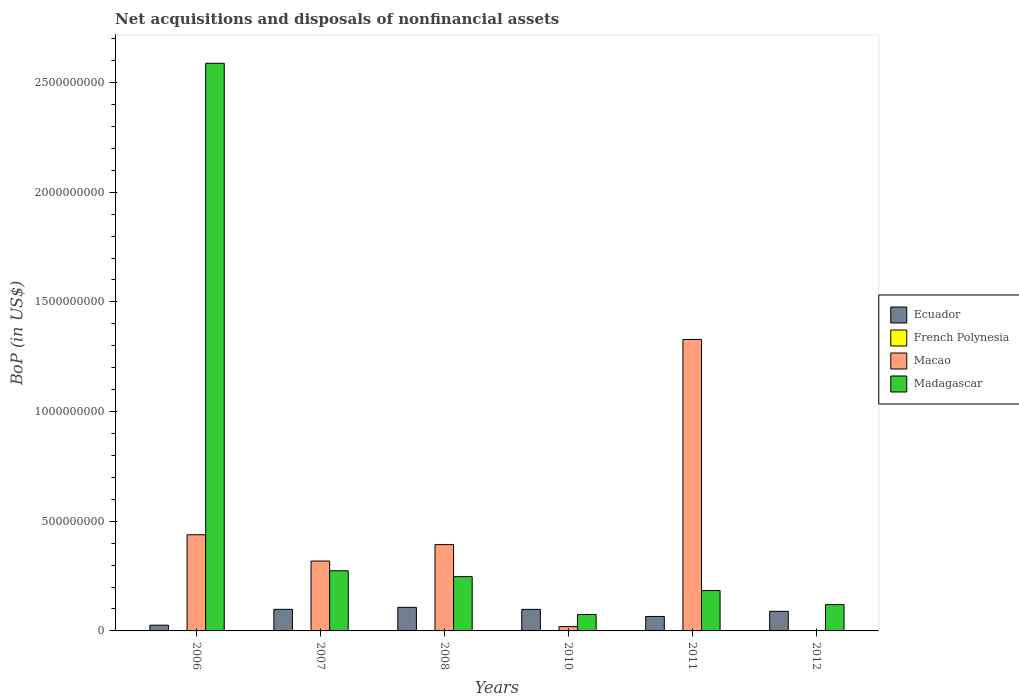How many different coloured bars are there?
Give a very brief answer. 4. How many groups of bars are there?
Give a very brief answer. 6. Are the number of bars per tick equal to the number of legend labels?
Give a very brief answer. No. Are the number of bars on each tick of the X-axis equal?
Your answer should be compact. No. How many bars are there on the 6th tick from the left?
Provide a succinct answer. 2. How many bars are there on the 4th tick from the right?
Give a very brief answer. 4. What is the Balance of Payments in Madagascar in 2011?
Offer a very short reply. 1.84e+08. Across all years, what is the maximum Balance of Payments in Madagascar?
Your response must be concise. 2.59e+09. Across all years, what is the minimum Balance of Payments in French Polynesia?
Your answer should be very brief. 0. What is the total Balance of Payments in Macao in the graph?
Offer a terse response. 2.50e+09. What is the difference between the Balance of Payments in Macao in 2006 and that in 2011?
Provide a succinct answer. -8.90e+08. What is the difference between the Balance of Payments in Madagascar in 2008 and the Balance of Payments in Ecuador in 2011?
Provide a short and direct response. 1.81e+08. What is the average Balance of Payments in Madagascar per year?
Keep it short and to the point. 5.81e+08. In the year 2008, what is the difference between the Balance of Payments in French Polynesia and Balance of Payments in Ecuador?
Your answer should be very brief. -1.07e+08. In how many years, is the Balance of Payments in French Polynesia greater than 100000000 US$?
Your answer should be compact. 0. What is the ratio of the Balance of Payments in Ecuador in 2008 to that in 2010?
Offer a terse response. 1.09. Is the Balance of Payments in Madagascar in 2010 less than that in 2012?
Your answer should be compact. Yes. What is the difference between the highest and the second highest Balance of Payments in Madagascar?
Your answer should be very brief. 2.31e+09. What is the difference between the highest and the lowest Balance of Payments in Ecuador?
Offer a very short reply. 8.13e+07. In how many years, is the Balance of Payments in Macao greater than the average Balance of Payments in Macao taken over all years?
Offer a very short reply. 2. Is it the case that in every year, the sum of the Balance of Payments in Ecuador and Balance of Payments in French Polynesia is greater than the Balance of Payments in Madagascar?
Give a very brief answer. No. Are all the bars in the graph horizontal?
Offer a very short reply. No. What is the difference between two consecutive major ticks on the Y-axis?
Offer a terse response. 5.00e+08. Are the values on the major ticks of Y-axis written in scientific E-notation?
Ensure brevity in your answer.  No. Does the graph contain grids?
Ensure brevity in your answer.  No. How are the legend labels stacked?
Your answer should be compact. Vertical. What is the title of the graph?
Ensure brevity in your answer.  Net acquisitions and disposals of nonfinancial assets. What is the label or title of the X-axis?
Give a very brief answer. Years. What is the label or title of the Y-axis?
Offer a very short reply. BoP (in US$). What is the BoP (in US$) in Ecuador in 2006?
Your answer should be compact. 2.61e+07. What is the BoP (in US$) in French Polynesia in 2006?
Your answer should be very brief. 0. What is the BoP (in US$) of Macao in 2006?
Give a very brief answer. 4.38e+08. What is the BoP (in US$) of Madagascar in 2006?
Offer a very short reply. 2.59e+09. What is the BoP (in US$) in Ecuador in 2007?
Offer a very short reply. 9.84e+07. What is the BoP (in US$) in French Polynesia in 2007?
Your answer should be very brief. 0. What is the BoP (in US$) in Macao in 2007?
Give a very brief answer. 3.19e+08. What is the BoP (in US$) of Madagascar in 2007?
Provide a short and direct response. 2.74e+08. What is the BoP (in US$) in Ecuador in 2008?
Offer a very short reply. 1.07e+08. What is the BoP (in US$) in French Polynesia in 2008?
Provide a short and direct response. 8350.98. What is the BoP (in US$) of Macao in 2008?
Offer a terse response. 3.93e+08. What is the BoP (in US$) of Madagascar in 2008?
Keep it short and to the point. 2.47e+08. What is the BoP (in US$) in Ecuador in 2010?
Your response must be concise. 9.82e+07. What is the BoP (in US$) in French Polynesia in 2010?
Your answer should be compact. 0. What is the BoP (in US$) in Macao in 2010?
Offer a terse response. 1.96e+07. What is the BoP (in US$) in Madagascar in 2010?
Your response must be concise. 7.49e+07. What is the BoP (in US$) of Ecuador in 2011?
Provide a short and direct response. 6.60e+07. What is the BoP (in US$) in French Polynesia in 2011?
Your answer should be very brief. 0. What is the BoP (in US$) in Macao in 2011?
Your response must be concise. 1.33e+09. What is the BoP (in US$) in Madagascar in 2011?
Ensure brevity in your answer.  1.84e+08. What is the BoP (in US$) of Ecuador in 2012?
Make the answer very short. 8.94e+07. What is the BoP (in US$) of French Polynesia in 2012?
Your answer should be compact. 0. What is the BoP (in US$) in Madagascar in 2012?
Keep it short and to the point. 1.20e+08. Across all years, what is the maximum BoP (in US$) in Ecuador?
Offer a terse response. 1.07e+08. Across all years, what is the maximum BoP (in US$) in French Polynesia?
Offer a very short reply. 8350.98. Across all years, what is the maximum BoP (in US$) in Macao?
Your answer should be very brief. 1.33e+09. Across all years, what is the maximum BoP (in US$) of Madagascar?
Offer a terse response. 2.59e+09. Across all years, what is the minimum BoP (in US$) of Ecuador?
Offer a terse response. 2.61e+07. Across all years, what is the minimum BoP (in US$) of French Polynesia?
Give a very brief answer. 0. Across all years, what is the minimum BoP (in US$) of Macao?
Your answer should be very brief. 0. Across all years, what is the minimum BoP (in US$) in Madagascar?
Make the answer very short. 7.49e+07. What is the total BoP (in US$) of Ecuador in the graph?
Offer a very short reply. 4.86e+08. What is the total BoP (in US$) of French Polynesia in the graph?
Provide a short and direct response. 8350.98. What is the total BoP (in US$) in Macao in the graph?
Give a very brief answer. 2.50e+09. What is the total BoP (in US$) of Madagascar in the graph?
Your answer should be very brief. 3.49e+09. What is the difference between the BoP (in US$) of Ecuador in 2006 and that in 2007?
Offer a terse response. -7.23e+07. What is the difference between the BoP (in US$) in Macao in 2006 and that in 2007?
Offer a very short reply. 1.20e+08. What is the difference between the BoP (in US$) in Madagascar in 2006 and that in 2007?
Ensure brevity in your answer.  2.31e+09. What is the difference between the BoP (in US$) of Ecuador in 2006 and that in 2008?
Your answer should be very brief. -8.13e+07. What is the difference between the BoP (in US$) of Macao in 2006 and that in 2008?
Your answer should be very brief. 4.50e+07. What is the difference between the BoP (in US$) in Madagascar in 2006 and that in 2008?
Provide a short and direct response. 2.34e+09. What is the difference between the BoP (in US$) of Ecuador in 2006 and that in 2010?
Your answer should be very brief. -7.21e+07. What is the difference between the BoP (in US$) of Macao in 2006 and that in 2010?
Your response must be concise. 4.19e+08. What is the difference between the BoP (in US$) of Madagascar in 2006 and that in 2010?
Provide a succinct answer. 2.51e+09. What is the difference between the BoP (in US$) of Ecuador in 2006 and that in 2011?
Make the answer very short. -3.99e+07. What is the difference between the BoP (in US$) in Macao in 2006 and that in 2011?
Your response must be concise. -8.90e+08. What is the difference between the BoP (in US$) in Madagascar in 2006 and that in 2011?
Offer a terse response. 2.40e+09. What is the difference between the BoP (in US$) in Ecuador in 2006 and that in 2012?
Ensure brevity in your answer.  -6.33e+07. What is the difference between the BoP (in US$) in Madagascar in 2006 and that in 2012?
Provide a short and direct response. 2.47e+09. What is the difference between the BoP (in US$) of Ecuador in 2007 and that in 2008?
Provide a short and direct response. -9.01e+06. What is the difference between the BoP (in US$) of Macao in 2007 and that in 2008?
Offer a very short reply. -7.49e+07. What is the difference between the BoP (in US$) of Madagascar in 2007 and that in 2008?
Your answer should be compact. 2.68e+07. What is the difference between the BoP (in US$) of Ecuador in 2007 and that in 2010?
Your response must be concise. 1.95e+05. What is the difference between the BoP (in US$) of Macao in 2007 and that in 2010?
Give a very brief answer. 2.99e+08. What is the difference between the BoP (in US$) of Madagascar in 2007 and that in 2010?
Provide a succinct answer. 1.99e+08. What is the difference between the BoP (in US$) of Ecuador in 2007 and that in 2011?
Offer a very short reply. 3.24e+07. What is the difference between the BoP (in US$) in Macao in 2007 and that in 2011?
Offer a terse response. -1.01e+09. What is the difference between the BoP (in US$) in Madagascar in 2007 and that in 2011?
Provide a succinct answer. 9.04e+07. What is the difference between the BoP (in US$) of Ecuador in 2007 and that in 2012?
Offer a very short reply. 9.05e+06. What is the difference between the BoP (in US$) in Madagascar in 2007 and that in 2012?
Make the answer very short. 1.54e+08. What is the difference between the BoP (in US$) in Ecuador in 2008 and that in 2010?
Offer a terse response. 9.21e+06. What is the difference between the BoP (in US$) of Macao in 2008 and that in 2010?
Your answer should be compact. 3.74e+08. What is the difference between the BoP (in US$) of Madagascar in 2008 and that in 2010?
Your answer should be compact. 1.72e+08. What is the difference between the BoP (in US$) in Ecuador in 2008 and that in 2011?
Offer a very short reply. 4.14e+07. What is the difference between the BoP (in US$) in Macao in 2008 and that in 2011?
Ensure brevity in your answer.  -9.35e+08. What is the difference between the BoP (in US$) of Madagascar in 2008 and that in 2011?
Make the answer very short. 6.35e+07. What is the difference between the BoP (in US$) of Ecuador in 2008 and that in 2012?
Offer a very short reply. 1.81e+07. What is the difference between the BoP (in US$) in Madagascar in 2008 and that in 2012?
Keep it short and to the point. 1.27e+08. What is the difference between the BoP (in US$) of Ecuador in 2010 and that in 2011?
Make the answer very short. 3.22e+07. What is the difference between the BoP (in US$) of Macao in 2010 and that in 2011?
Give a very brief answer. -1.31e+09. What is the difference between the BoP (in US$) in Madagascar in 2010 and that in 2011?
Keep it short and to the point. -1.09e+08. What is the difference between the BoP (in US$) in Ecuador in 2010 and that in 2012?
Your answer should be compact. 8.86e+06. What is the difference between the BoP (in US$) of Madagascar in 2010 and that in 2012?
Provide a short and direct response. -4.50e+07. What is the difference between the BoP (in US$) in Ecuador in 2011 and that in 2012?
Your answer should be very brief. -2.34e+07. What is the difference between the BoP (in US$) of Madagascar in 2011 and that in 2012?
Provide a short and direct response. 6.40e+07. What is the difference between the BoP (in US$) of Ecuador in 2006 and the BoP (in US$) of Macao in 2007?
Make the answer very short. -2.92e+08. What is the difference between the BoP (in US$) in Ecuador in 2006 and the BoP (in US$) in Madagascar in 2007?
Make the answer very short. -2.48e+08. What is the difference between the BoP (in US$) in Macao in 2006 and the BoP (in US$) in Madagascar in 2007?
Ensure brevity in your answer.  1.64e+08. What is the difference between the BoP (in US$) of Ecuador in 2006 and the BoP (in US$) of French Polynesia in 2008?
Provide a short and direct response. 2.61e+07. What is the difference between the BoP (in US$) in Ecuador in 2006 and the BoP (in US$) in Macao in 2008?
Offer a terse response. -3.67e+08. What is the difference between the BoP (in US$) in Ecuador in 2006 and the BoP (in US$) in Madagascar in 2008?
Your response must be concise. -2.21e+08. What is the difference between the BoP (in US$) in Macao in 2006 and the BoP (in US$) in Madagascar in 2008?
Your answer should be compact. 1.91e+08. What is the difference between the BoP (in US$) in Ecuador in 2006 and the BoP (in US$) in Macao in 2010?
Ensure brevity in your answer.  6.51e+06. What is the difference between the BoP (in US$) of Ecuador in 2006 and the BoP (in US$) of Madagascar in 2010?
Ensure brevity in your answer.  -4.88e+07. What is the difference between the BoP (in US$) of Macao in 2006 and the BoP (in US$) of Madagascar in 2010?
Your answer should be very brief. 3.64e+08. What is the difference between the BoP (in US$) of Ecuador in 2006 and the BoP (in US$) of Macao in 2011?
Your response must be concise. -1.30e+09. What is the difference between the BoP (in US$) in Ecuador in 2006 and the BoP (in US$) in Madagascar in 2011?
Your response must be concise. -1.58e+08. What is the difference between the BoP (in US$) in Macao in 2006 and the BoP (in US$) in Madagascar in 2011?
Your answer should be compact. 2.55e+08. What is the difference between the BoP (in US$) in Ecuador in 2006 and the BoP (in US$) in Madagascar in 2012?
Offer a very short reply. -9.38e+07. What is the difference between the BoP (in US$) in Macao in 2006 and the BoP (in US$) in Madagascar in 2012?
Provide a succinct answer. 3.19e+08. What is the difference between the BoP (in US$) in Ecuador in 2007 and the BoP (in US$) in French Polynesia in 2008?
Give a very brief answer. 9.84e+07. What is the difference between the BoP (in US$) of Ecuador in 2007 and the BoP (in US$) of Macao in 2008?
Your response must be concise. -2.95e+08. What is the difference between the BoP (in US$) of Ecuador in 2007 and the BoP (in US$) of Madagascar in 2008?
Provide a succinct answer. -1.49e+08. What is the difference between the BoP (in US$) of Macao in 2007 and the BoP (in US$) of Madagascar in 2008?
Keep it short and to the point. 7.12e+07. What is the difference between the BoP (in US$) in Ecuador in 2007 and the BoP (in US$) in Macao in 2010?
Ensure brevity in your answer.  7.88e+07. What is the difference between the BoP (in US$) of Ecuador in 2007 and the BoP (in US$) of Madagascar in 2010?
Ensure brevity in your answer.  2.35e+07. What is the difference between the BoP (in US$) in Macao in 2007 and the BoP (in US$) in Madagascar in 2010?
Keep it short and to the point. 2.44e+08. What is the difference between the BoP (in US$) in Ecuador in 2007 and the BoP (in US$) in Macao in 2011?
Offer a terse response. -1.23e+09. What is the difference between the BoP (in US$) of Ecuador in 2007 and the BoP (in US$) of Madagascar in 2011?
Your answer should be very brief. -8.55e+07. What is the difference between the BoP (in US$) of Macao in 2007 and the BoP (in US$) of Madagascar in 2011?
Keep it short and to the point. 1.35e+08. What is the difference between the BoP (in US$) in Ecuador in 2007 and the BoP (in US$) in Madagascar in 2012?
Make the answer very short. -2.15e+07. What is the difference between the BoP (in US$) of Macao in 2007 and the BoP (in US$) of Madagascar in 2012?
Provide a succinct answer. 1.99e+08. What is the difference between the BoP (in US$) of Ecuador in 2008 and the BoP (in US$) of Macao in 2010?
Make the answer very short. 8.78e+07. What is the difference between the BoP (in US$) of Ecuador in 2008 and the BoP (in US$) of Madagascar in 2010?
Provide a short and direct response. 3.25e+07. What is the difference between the BoP (in US$) in French Polynesia in 2008 and the BoP (in US$) in Macao in 2010?
Your response must be concise. -1.96e+07. What is the difference between the BoP (in US$) of French Polynesia in 2008 and the BoP (in US$) of Madagascar in 2010?
Give a very brief answer. -7.49e+07. What is the difference between the BoP (in US$) of Macao in 2008 and the BoP (in US$) of Madagascar in 2010?
Ensure brevity in your answer.  3.19e+08. What is the difference between the BoP (in US$) in Ecuador in 2008 and the BoP (in US$) in Macao in 2011?
Offer a very short reply. -1.22e+09. What is the difference between the BoP (in US$) in Ecuador in 2008 and the BoP (in US$) in Madagascar in 2011?
Your answer should be compact. -7.64e+07. What is the difference between the BoP (in US$) of French Polynesia in 2008 and the BoP (in US$) of Macao in 2011?
Your response must be concise. -1.33e+09. What is the difference between the BoP (in US$) of French Polynesia in 2008 and the BoP (in US$) of Madagascar in 2011?
Offer a very short reply. -1.84e+08. What is the difference between the BoP (in US$) of Macao in 2008 and the BoP (in US$) of Madagascar in 2011?
Provide a short and direct response. 2.10e+08. What is the difference between the BoP (in US$) in Ecuador in 2008 and the BoP (in US$) in Madagascar in 2012?
Make the answer very short. -1.25e+07. What is the difference between the BoP (in US$) of French Polynesia in 2008 and the BoP (in US$) of Madagascar in 2012?
Provide a succinct answer. -1.20e+08. What is the difference between the BoP (in US$) in Macao in 2008 and the BoP (in US$) in Madagascar in 2012?
Your response must be concise. 2.74e+08. What is the difference between the BoP (in US$) in Ecuador in 2010 and the BoP (in US$) in Macao in 2011?
Offer a terse response. -1.23e+09. What is the difference between the BoP (in US$) of Ecuador in 2010 and the BoP (in US$) of Madagascar in 2011?
Your answer should be very brief. -8.57e+07. What is the difference between the BoP (in US$) of Macao in 2010 and the BoP (in US$) of Madagascar in 2011?
Your response must be concise. -1.64e+08. What is the difference between the BoP (in US$) in Ecuador in 2010 and the BoP (in US$) in Madagascar in 2012?
Provide a short and direct response. -2.17e+07. What is the difference between the BoP (in US$) in Macao in 2010 and the BoP (in US$) in Madagascar in 2012?
Your answer should be very brief. -1.00e+08. What is the difference between the BoP (in US$) in Ecuador in 2011 and the BoP (in US$) in Madagascar in 2012?
Keep it short and to the point. -5.39e+07. What is the difference between the BoP (in US$) in Macao in 2011 and the BoP (in US$) in Madagascar in 2012?
Your answer should be compact. 1.21e+09. What is the average BoP (in US$) in Ecuador per year?
Offer a very short reply. 8.09e+07. What is the average BoP (in US$) in French Polynesia per year?
Ensure brevity in your answer.  1391.83. What is the average BoP (in US$) in Macao per year?
Provide a succinct answer. 4.16e+08. What is the average BoP (in US$) of Madagascar per year?
Provide a succinct answer. 5.81e+08. In the year 2006, what is the difference between the BoP (in US$) of Ecuador and BoP (in US$) of Macao?
Make the answer very short. -4.12e+08. In the year 2006, what is the difference between the BoP (in US$) in Ecuador and BoP (in US$) in Madagascar?
Ensure brevity in your answer.  -2.56e+09. In the year 2006, what is the difference between the BoP (in US$) of Macao and BoP (in US$) of Madagascar?
Provide a succinct answer. -2.15e+09. In the year 2007, what is the difference between the BoP (in US$) in Ecuador and BoP (in US$) in Macao?
Make the answer very short. -2.20e+08. In the year 2007, what is the difference between the BoP (in US$) of Ecuador and BoP (in US$) of Madagascar?
Your answer should be very brief. -1.76e+08. In the year 2007, what is the difference between the BoP (in US$) of Macao and BoP (in US$) of Madagascar?
Ensure brevity in your answer.  4.44e+07. In the year 2008, what is the difference between the BoP (in US$) in Ecuador and BoP (in US$) in French Polynesia?
Offer a terse response. 1.07e+08. In the year 2008, what is the difference between the BoP (in US$) in Ecuador and BoP (in US$) in Macao?
Provide a succinct answer. -2.86e+08. In the year 2008, what is the difference between the BoP (in US$) of Ecuador and BoP (in US$) of Madagascar?
Offer a terse response. -1.40e+08. In the year 2008, what is the difference between the BoP (in US$) of French Polynesia and BoP (in US$) of Macao?
Ensure brevity in your answer.  -3.93e+08. In the year 2008, what is the difference between the BoP (in US$) of French Polynesia and BoP (in US$) of Madagascar?
Your answer should be compact. -2.47e+08. In the year 2008, what is the difference between the BoP (in US$) in Macao and BoP (in US$) in Madagascar?
Keep it short and to the point. 1.46e+08. In the year 2010, what is the difference between the BoP (in US$) of Ecuador and BoP (in US$) of Macao?
Offer a very short reply. 7.86e+07. In the year 2010, what is the difference between the BoP (in US$) in Ecuador and BoP (in US$) in Madagascar?
Provide a short and direct response. 2.33e+07. In the year 2010, what is the difference between the BoP (in US$) in Macao and BoP (in US$) in Madagascar?
Offer a terse response. -5.53e+07. In the year 2011, what is the difference between the BoP (in US$) in Ecuador and BoP (in US$) in Macao?
Make the answer very short. -1.26e+09. In the year 2011, what is the difference between the BoP (in US$) in Ecuador and BoP (in US$) in Madagascar?
Ensure brevity in your answer.  -1.18e+08. In the year 2011, what is the difference between the BoP (in US$) of Macao and BoP (in US$) of Madagascar?
Offer a very short reply. 1.14e+09. In the year 2012, what is the difference between the BoP (in US$) in Ecuador and BoP (in US$) in Madagascar?
Provide a succinct answer. -3.06e+07. What is the ratio of the BoP (in US$) in Ecuador in 2006 to that in 2007?
Offer a terse response. 0.27. What is the ratio of the BoP (in US$) in Macao in 2006 to that in 2007?
Your answer should be compact. 1.38. What is the ratio of the BoP (in US$) of Madagascar in 2006 to that in 2007?
Offer a very short reply. 9.44. What is the ratio of the BoP (in US$) of Ecuador in 2006 to that in 2008?
Offer a very short reply. 0.24. What is the ratio of the BoP (in US$) of Macao in 2006 to that in 2008?
Provide a short and direct response. 1.11. What is the ratio of the BoP (in US$) of Madagascar in 2006 to that in 2008?
Your answer should be very brief. 10.46. What is the ratio of the BoP (in US$) in Ecuador in 2006 to that in 2010?
Ensure brevity in your answer.  0.27. What is the ratio of the BoP (in US$) in Macao in 2006 to that in 2010?
Offer a terse response. 22.37. What is the ratio of the BoP (in US$) in Madagascar in 2006 to that in 2010?
Your answer should be very brief. 34.54. What is the ratio of the BoP (in US$) of Ecuador in 2006 to that in 2011?
Provide a succinct answer. 0.4. What is the ratio of the BoP (in US$) of Macao in 2006 to that in 2011?
Keep it short and to the point. 0.33. What is the ratio of the BoP (in US$) in Madagascar in 2006 to that in 2011?
Provide a succinct answer. 14.07. What is the ratio of the BoP (in US$) of Ecuador in 2006 to that in 2012?
Your answer should be compact. 0.29. What is the ratio of the BoP (in US$) of Madagascar in 2006 to that in 2012?
Give a very brief answer. 21.58. What is the ratio of the BoP (in US$) of Ecuador in 2007 to that in 2008?
Your answer should be very brief. 0.92. What is the ratio of the BoP (in US$) of Macao in 2007 to that in 2008?
Offer a very short reply. 0.81. What is the ratio of the BoP (in US$) in Madagascar in 2007 to that in 2008?
Offer a very short reply. 1.11. What is the ratio of the BoP (in US$) of Macao in 2007 to that in 2010?
Your answer should be very brief. 16.26. What is the ratio of the BoP (in US$) in Madagascar in 2007 to that in 2010?
Keep it short and to the point. 3.66. What is the ratio of the BoP (in US$) in Ecuador in 2007 to that in 2011?
Your response must be concise. 1.49. What is the ratio of the BoP (in US$) in Macao in 2007 to that in 2011?
Keep it short and to the point. 0.24. What is the ratio of the BoP (in US$) of Madagascar in 2007 to that in 2011?
Give a very brief answer. 1.49. What is the ratio of the BoP (in US$) in Ecuador in 2007 to that in 2012?
Give a very brief answer. 1.1. What is the ratio of the BoP (in US$) in Madagascar in 2007 to that in 2012?
Make the answer very short. 2.29. What is the ratio of the BoP (in US$) in Ecuador in 2008 to that in 2010?
Keep it short and to the point. 1.09. What is the ratio of the BoP (in US$) in Macao in 2008 to that in 2010?
Your answer should be compact. 20.08. What is the ratio of the BoP (in US$) in Madagascar in 2008 to that in 2010?
Keep it short and to the point. 3.3. What is the ratio of the BoP (in US$) of Ecuador in 2008 to that in 2011?
Provide a short and direct response. 1.63. What is the ratio of the BoP (in US$) of Macao in 2008 to that in 2011?
Offer a very short reply. 0.3. What is the ratio of the BoP (in US$) in Madagascar in 2008 to that in 2011?
Ensure brevity in your answer.  1.35. What is the ratio of the BoP (in US$) of Ecuador in 2008 to that in 2012?
Ensure brevity in your answer.  1.2. What is the ratio of the BoP (in US$) in Madagascar in 2008 to that in 2012?
Your answer should be very brief. 2.06. What is the ratio of the BoP (in US$) of Ecuador in 2010 to that in 2011?
Your answer should be compact. 1.49. What is the ratio of the BoP (in US$) of Macao in 2010 to that in 2011?
Provide a short and direct response. 0.01. What is the ratio of the BoP (in US$) of Madagascar in 2010 to that in 2011?
Your answer should be very brief. 0.41. What is the ratio of the BoP (in US$) of Ecuador in 2010 to that in 2012?
Keep it short and to the point. 1.1. What is the ratio of the BoP (in US$) in Madagascar in 2010 to that in 2012?
Your answer should be very brief. 0.62. What is the ratio of the BoP (in US$) of Ecuador in 2011 to that in 2012?
Provide a short and direct response. 0.74. What is the ratio of the BoP (in US$) of Madagascar in 2011 to that in 2012?
Offer a very short reply. 1.53. What is the difference between the highest and the second highest BoP (in US$) in Ecuador?
Provide a short and direct response. 9.01e+06. What is the difference between the highest and the second highest BoP (in US$) in Macao?
Your answer should be very brief. 8.90e+08. What is the difference between the highest and the second highest BoP (in US$) in Madagascar?
Offer a very short reply. 2.31e+09. What is the difference between the highest and the lowest BoP (in US$) in Ecuador?
Your answer should be very brief. 8.13e+07. What is the difference between the highest and the lowest BoP (in US$) in French Polynesia?
Provide a succinct answer. 8350.98. What is the difference between the highest and the lowest BoP (in US$) of Macao?
Provide a succinct answer. 1.33e+09. What is the difference between the highest and the lowest BoP (in US$) in Madagascar?
Give a very brief answer. 2.51e+09. 